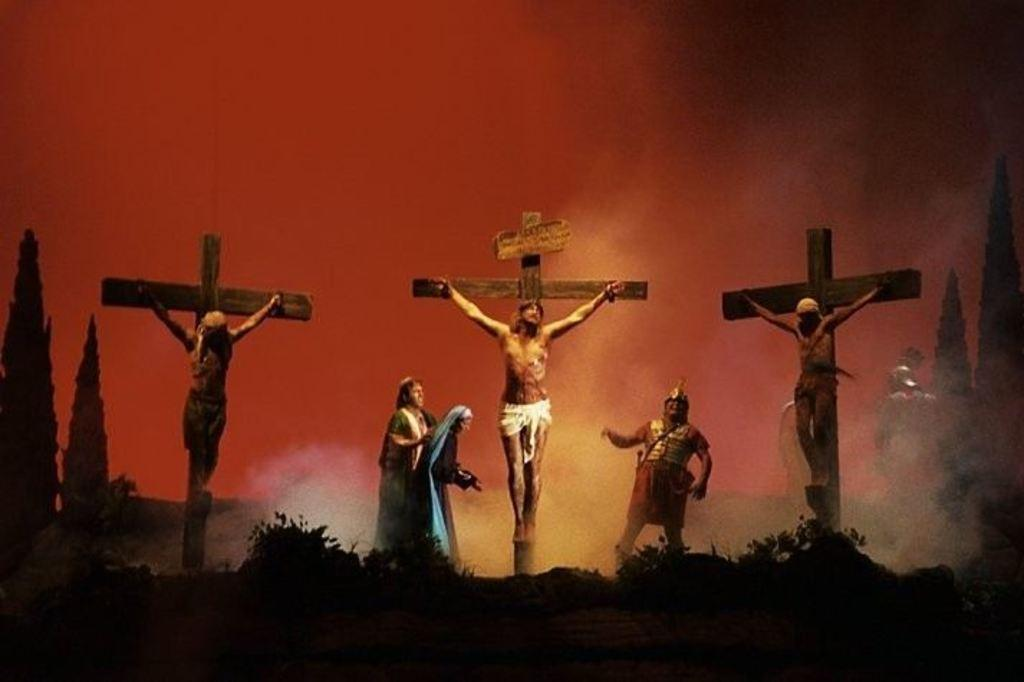What type of objects can be seen in the image? There are statues in the image. What other elements are present in the image besides statues? There are plants and trees in the image. What color is the background of the image? The background of the image is red. What type of locket can be seen hanging from the roof in the image? There is no locket or roof present in the image; it features statues, plants, and trees with a red background. 